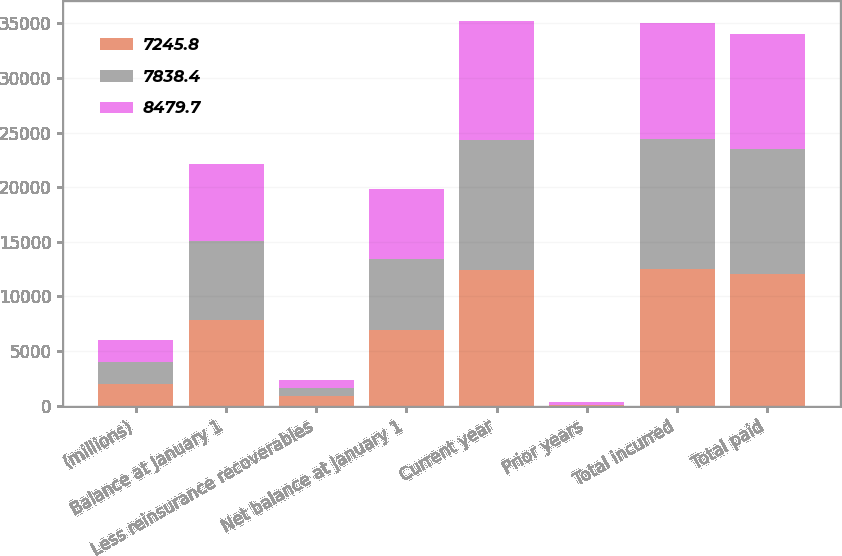Convert chart to OTSL. <chart><loc_0><loc_0><loc_500><loc_500><stacked_bar_chart><ecel><fcel>(millions)<fcel>Balance at January 1<fcel>Less reinsurance recoverables<fcel>Net balance at January 1<fcel>Current year<fcel>Prior years<fcel>Total incurred<fcel>Total paid<nl><fcel>7245.8<fcel>2013<fcel>7838.4<fcel>862.1<fcel>6976.3<fcel>12427.3<fcel>45.1<fcel>12472.4<fcel>12014.9<nl><fcel>7838.4<fcel>2012<fcel>7245.8<fcel>785.7<fcel>6460.1<fcel>11926<fcel>22<fcel>11948<fcel>11431.8<nl><fcel>8479.7<fcel>2011<fcel>7071<fcel>704.1<fcel>6366.9<fcel>10876.8<fcel>242<fcel>10634.8<fcel>10541.6<nl></chart> 